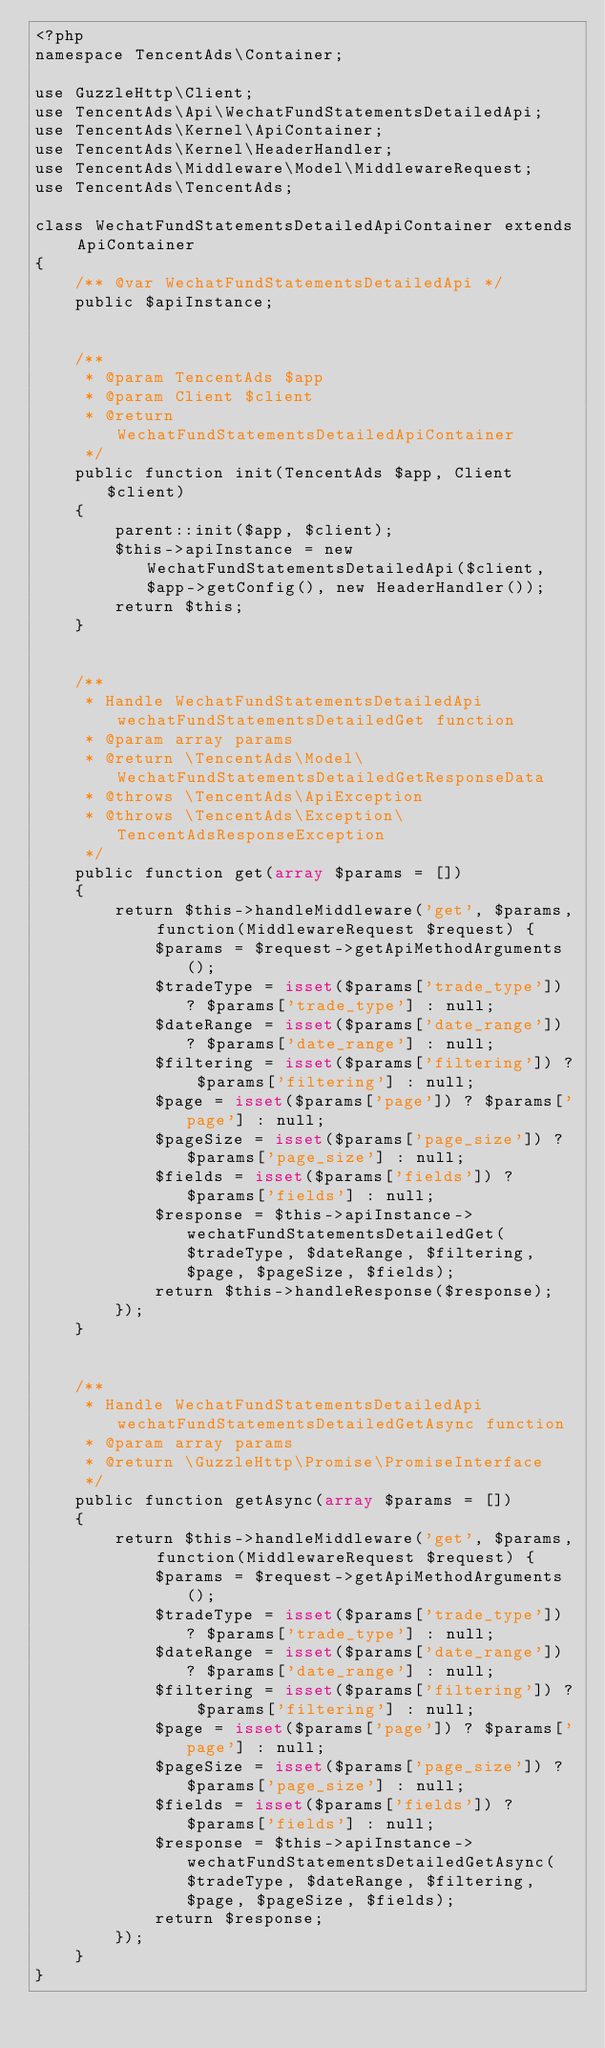Convert code to text. <code><loc_0><loc_0><loc_500><loc_500><_PHP_><?php
namespace TencentAds\Container;

use GuzzleHttp\Client;
use TencentAds\Api\WechatFundStatementsDetailedApi;
use TencentAds\Kernel\ApiContainer;
use TencentAds\Kernel\HeaderHandler;
use TencentAds\Middleware\Model\MiddlewareRequest;
use TencentAds\TencentAds;

class WechatFundStatementsDetailedApiContainer extends ApiContainer
{
    /** @var WechatFundStatementsDetailedApi */
    public $apiInstance;


    /**
     * @param TencentAds $app
     * @param Client $client
     * @return WechatFundStatementsDetailedApiContainer
     */
    public function init(TencentAds $app, Client $client)
    {
        parent::init($app, $client);
        $this->apiInstance = new WechatFundStatementsDetailedApi($client, $app->getConfig(), new HeaderHandler());
        return $this;
    }


    /**
     * Handle WechatFundStatementsDetailedApi wechatFundStatementsDetailedGet function
     * @param array params
     * @return \TencentAds\Model\WechatFundStatementsDetailedGetResponseData
     * @throws \TencentAds\ApiException
     * @throws \TencentAds\Exception\TencentAdsResponseException
     */
    public function get(array $params = [])
    {
        return $this->handleMiddleware('get', $params, function(MiddlewareRequest $request) {
            $params = $request->getApiMethodArguments();
            $tradeType = isset($params['trade_type']) ? $params['trade_type'] : null;
            $dateRange = isset($params['date_range']) ? $params['date_range'] : null;
            $filtering = isset($params['filtering']) ? $params['filtering'] : null;
            $page = isset($params['page']) ? $params['page'] : null;
            $pageSize = isset($params['page_size']) ? $params['page_size'] : null;
            $fields = isset($params['fields']) ? $params['fields'] : null;
            $response = $this->apiInstance->wechatFundStatementsDetailedGet($tradeType, $dateRange, $filtering, $page, $pageSize, $fields);
            return $this->handleResponse($response);
        });
    }


    /**
     * Handle WechatFundStatementsDetailedApi wechatFundStatementsDetailedGetAsync function
     * @param array params
     * @return \GuzzleHttp\Promise\PromiseInterface
     */
    public function getAsync(array $params = [])
    {
        return $this->handleMiddleware('get', $params, function(MiddlewareRequest $request) {
            $params = $request->getApiMethodArguments();
            $tradeType = isset($params['trade_type']) ? $params['trade_type'] : null;
            $dateRange = isset($params['date_range']) ? $params['date_range'] : null;
            $filtering = isset($params['filtering']) ? $params['filtering'] : null;
            $page = isset($params['page']) ? $params['page'] : null;
            $pageSize = isset($params['page_size']) ? $params['page_size'] : null;
            $fields = isset($params['fields']) ? $params['fields'] : null;
            $response = $this->apiInstance->wechatFundStatementsDetailedGetAsync($tradeType, $dateRange, $filtering, $page, $pageSize, $fields);
            return $response;
        });
    }
}
</code> 